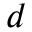Convert formula to latex. <formula><loc_0><loc_0><loc_500><loc_500>d</formula> 